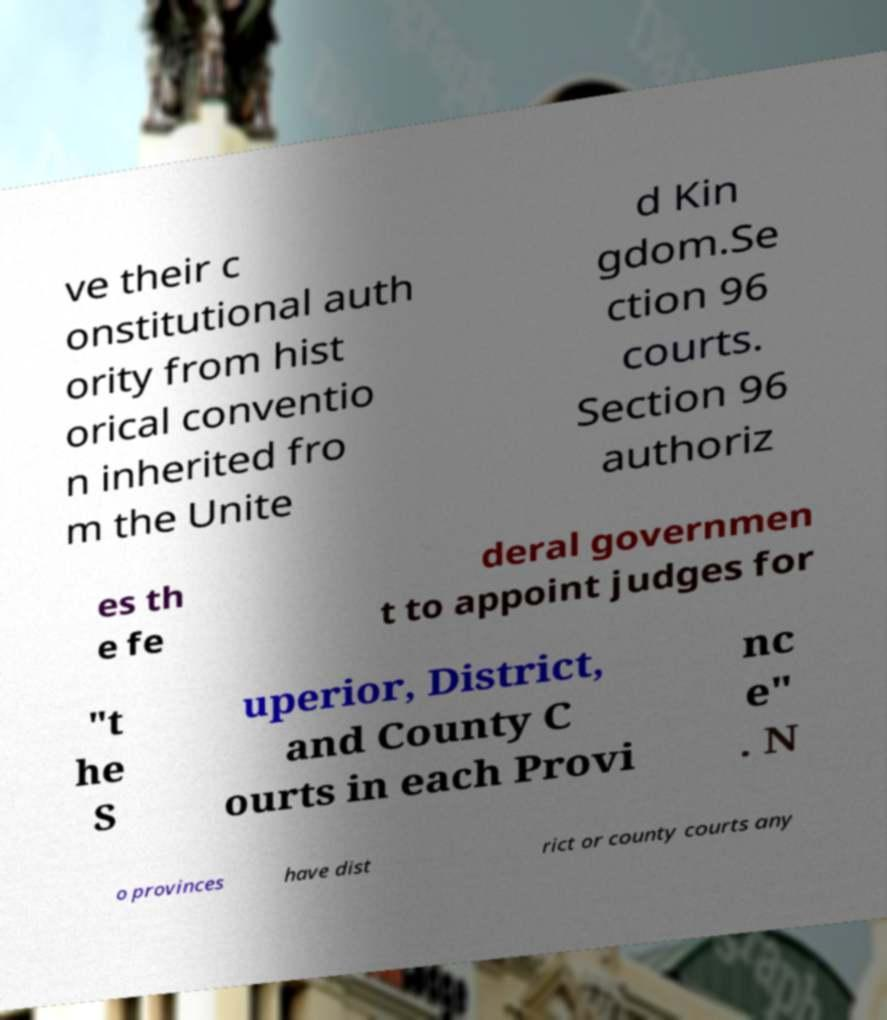Can you read and provide the text displayed in the image?This photo seems to have some interesting text. Can you extract and type it out for me? ve their c onstitutional auth ority from hist orical conventio n inherited fro m the Unite d Kin gdom.Se ction 96 courts. Section 96 authoriz es th e fe deral governmen t to appoint judges for "t he S uperior, District, and County C ourts in each Provi nc e" . N o provinces have dist rict or county courts any 